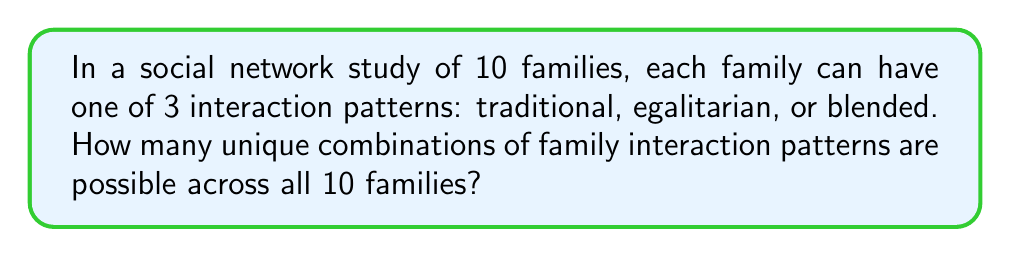What is the answer to this math problem? To solve this problem, we need to use the concept of combinations with repetition. Here's the step-by-step solution:

1) We have 10 families, and each family can have one of 3 interaction patterns.

2) This is equivalent to distributing 10 identical objects (families) into 3 distinct boxes (interaction patterns).

3) The formula for combinations with repetition is:

   $$\binom{n+r-1}{r-1} = \binom{n+r-1}{n}$$

   where $n$ is the number of identical objects and $r$ is the number of distinct boxes.

4) In this case, $n = 10$ (families) and $r = 3$ (interaction patterns).

5) Plugging these values into the formula:

   $$\binom{10+3-1}{3-1} = \binom{12}{2}$$

6) To calculate this combination:

   $$\binom{12}{2} = \frac{12!}{2!(12-2)!} = \frac{12!}{2!10!}$$

7) Simplifying:

   $$\frac{12 \cdot 11}{2 \cdot 1} = 66$$

Therefore, there are 66 unique combinations of family interaction patterns possible across the 10 families.
Answer: 66 